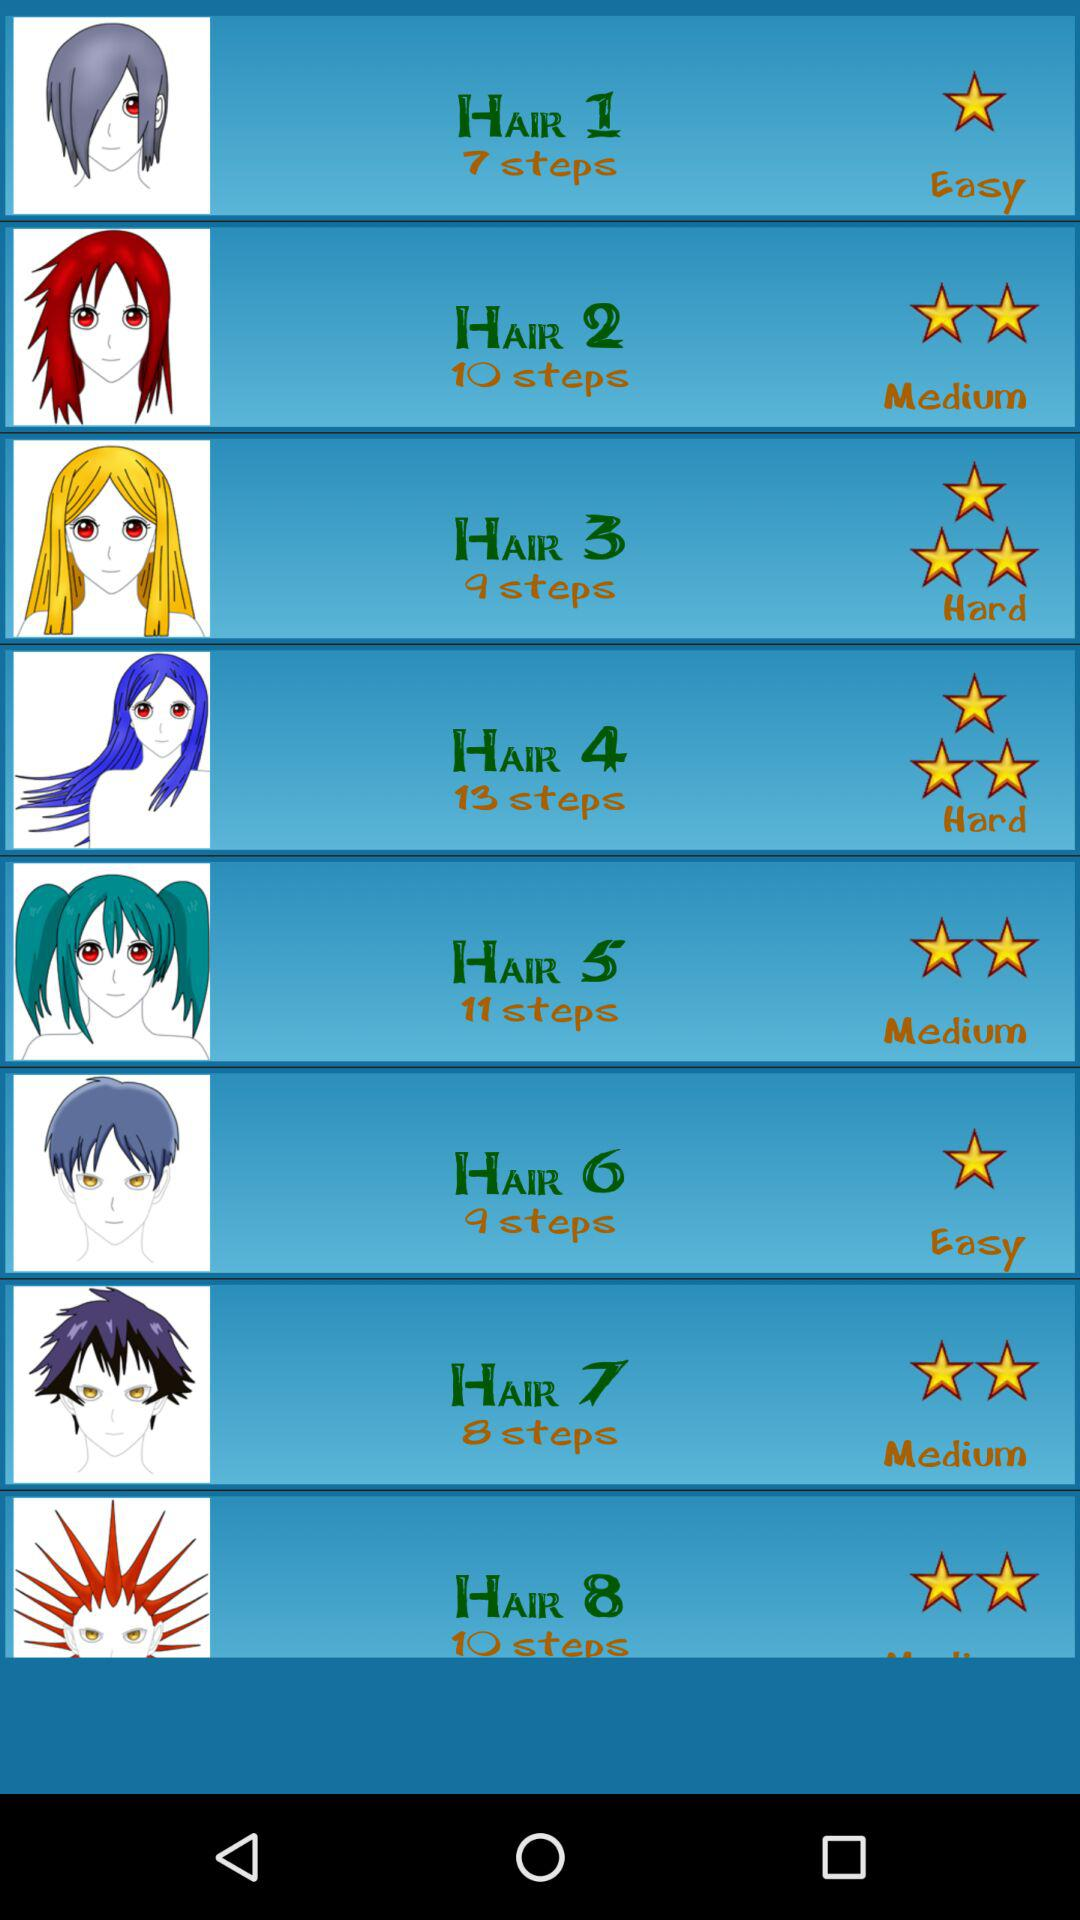Is "HAIR 2" easy, medium or hard? "HAIR 2" is medium. 